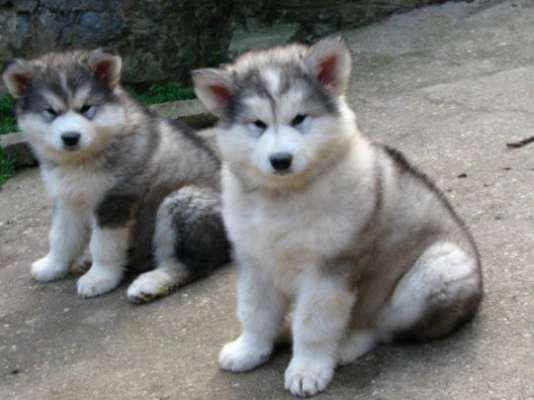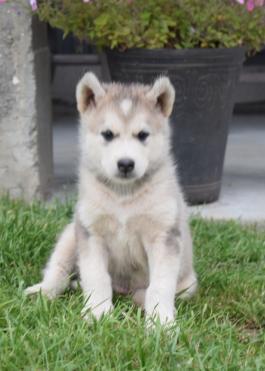The first image is the image on the left, the second image is the image on the right. Assess this claim about the two images: "The left and right image contains a total of six dogs.". Correct or not? Answer yes or no. No. The first image is the image on the left, the second image is the image on the right. Assess this claim about the two images: "The left image contains five forward-facing husky puppies in two different coat color combinations.". Correct or not? Answer yes or no. No. 